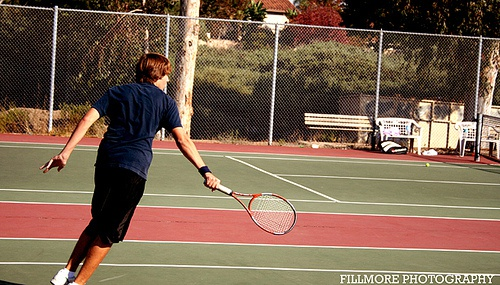Describe the objects in this image and their specific colors. I can see people in gray, black, navy, tan, and maroon tones, tennis racket in gray, lightpink, tan, and ivory tones, bench in gray, ivory, black, tan, and maroon tones, bench in gray, white, black, and tan tones, and bench in gray, white, tan, and black tones in this image. 